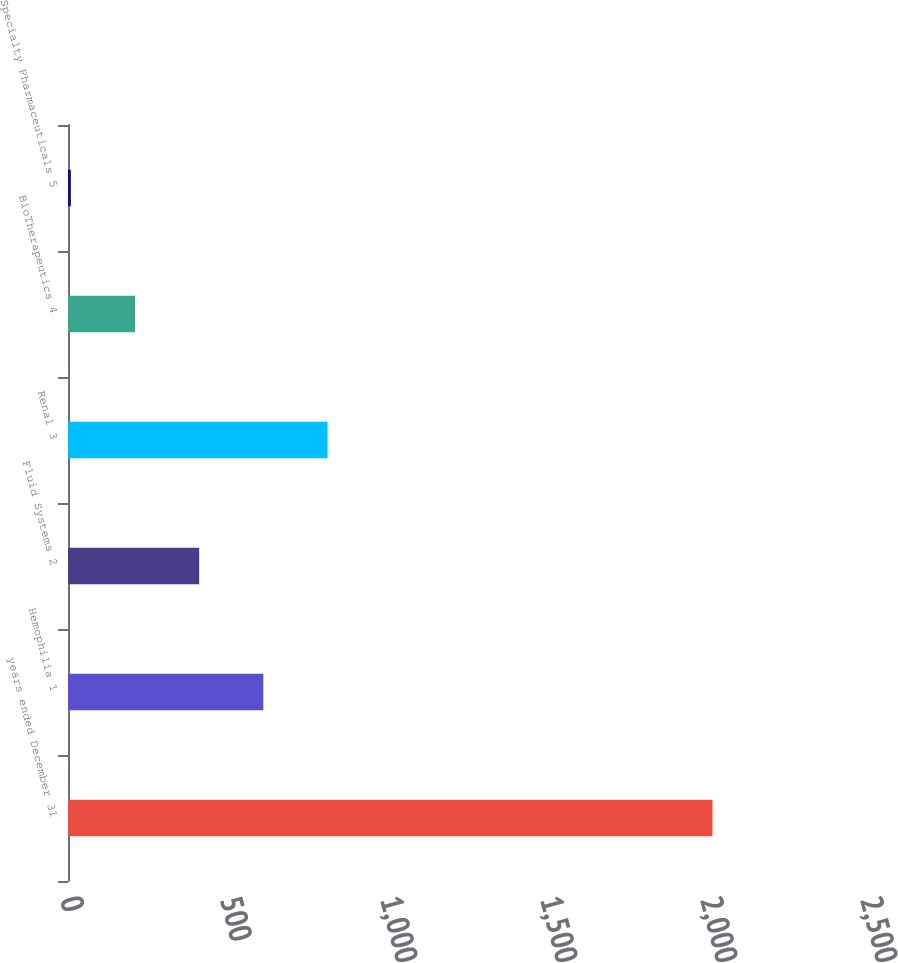<chart> <loc_0><loc_0><loc_500><loc_500><bar_chart><fcel>years ended December 31<fcel>Hemophilia 1<fcel>Fluid Systems 2<fcel>Renal 3<fcel>BioTherapeutics 4<fcel>Specialty Pharmaceuticals 5<nl><fcel>2014<fcel>610.5<fcel>410<fcel>811<fcel>209.5<fcel>9<nl></chart> 